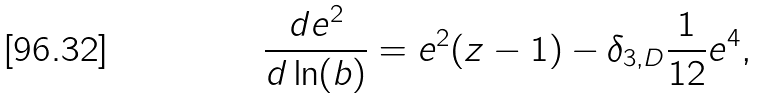<formula> <loc_0><loc_0><loc_500><loc_500>\frac { d e ^ { 2 } } { d \ln ( b ) } = e ^ { 2 } ( z - 1 ) - \delta _ { 3 , D } \frac { 1 } { 1 2 } e ^ { 4 } ,</formula> 